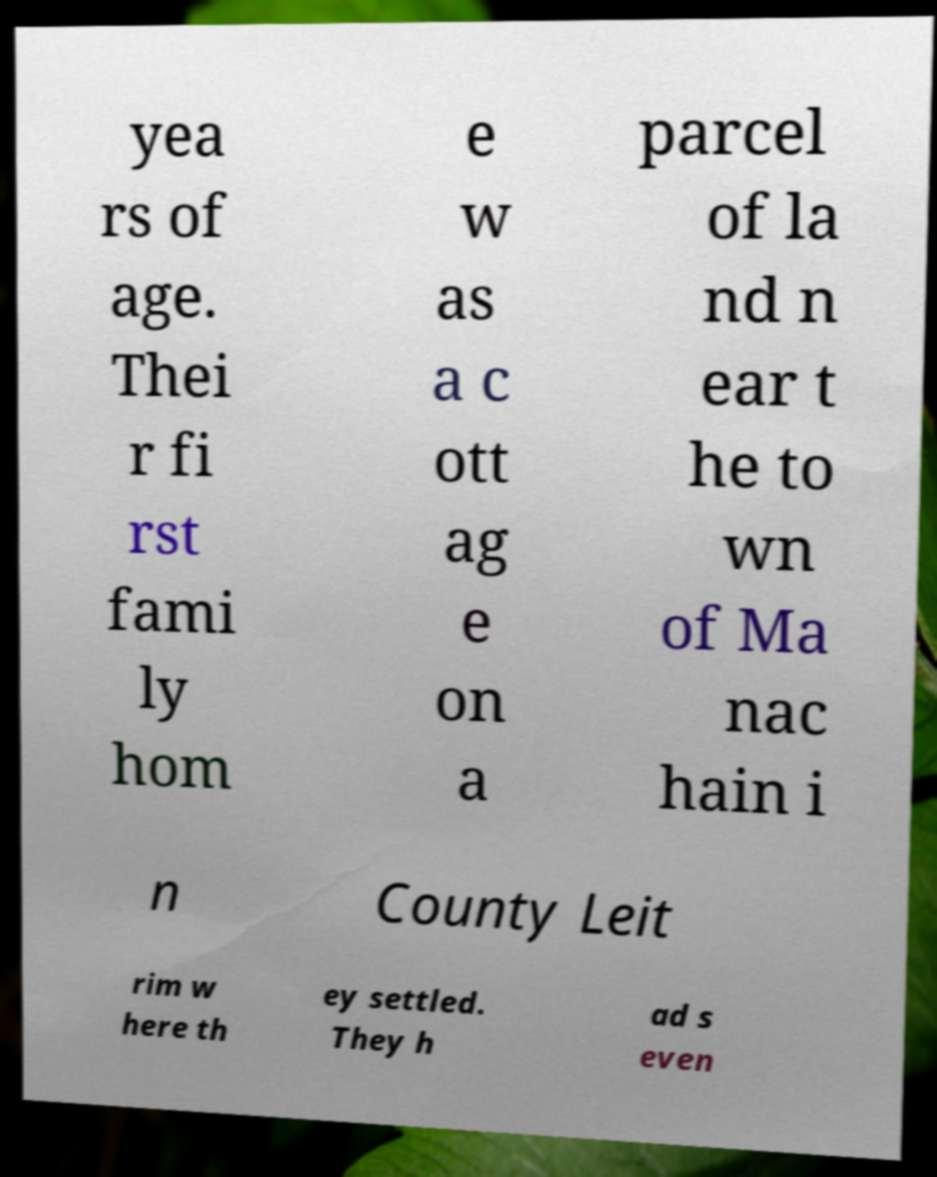Please read and relay the text visible in this image. What does it say? yea rs of age. Thei r fi rst fami ly hom e w as a c ott ag e on a parcel of la nd n ear t he to wn of Ma nac hain i n County Leit rim w here th ey settled. They h ad s even 